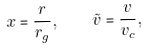<formula> <loc_0><loc_0><loc_500><loc_500>x = \frac { r } { r _ { g } } , \quad { \tilde { v } } = \frac { v } { v _ { c } } ,</formula> 